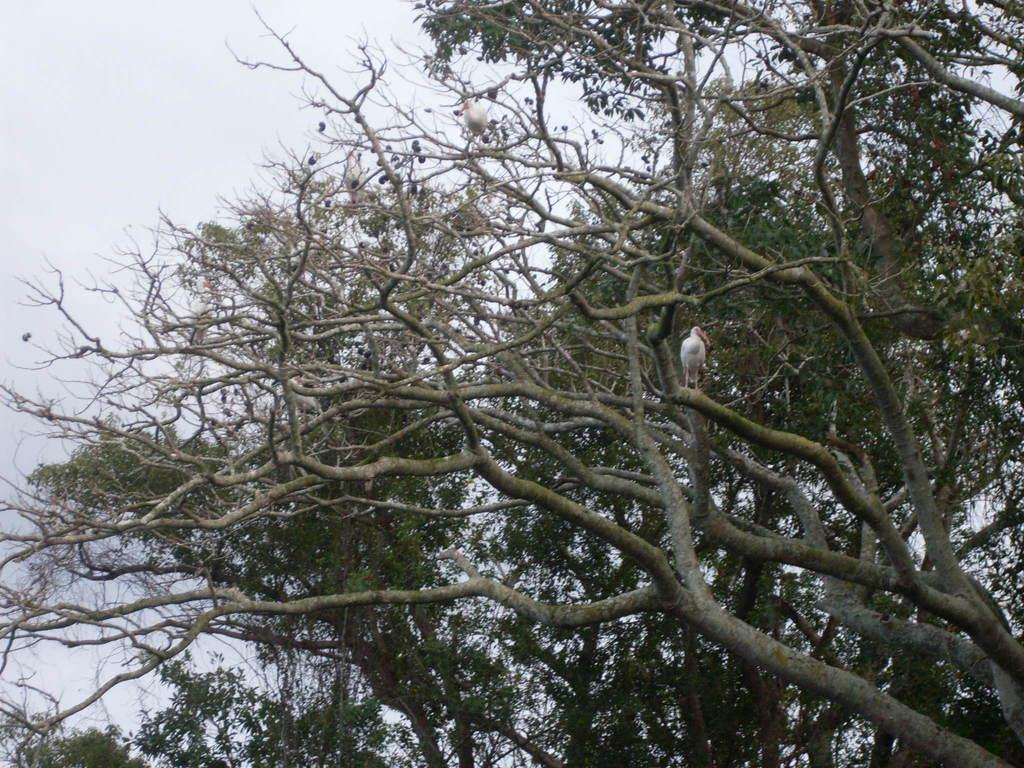What type of vegetation can be seen in the image? There are trees in the image. What animals are present on the trees? There are birds on the trees. What is visible at the top of the image? The sky is visible at the top of the image. How many pockets can be seen in the image? There are no pockets visible in the image. 